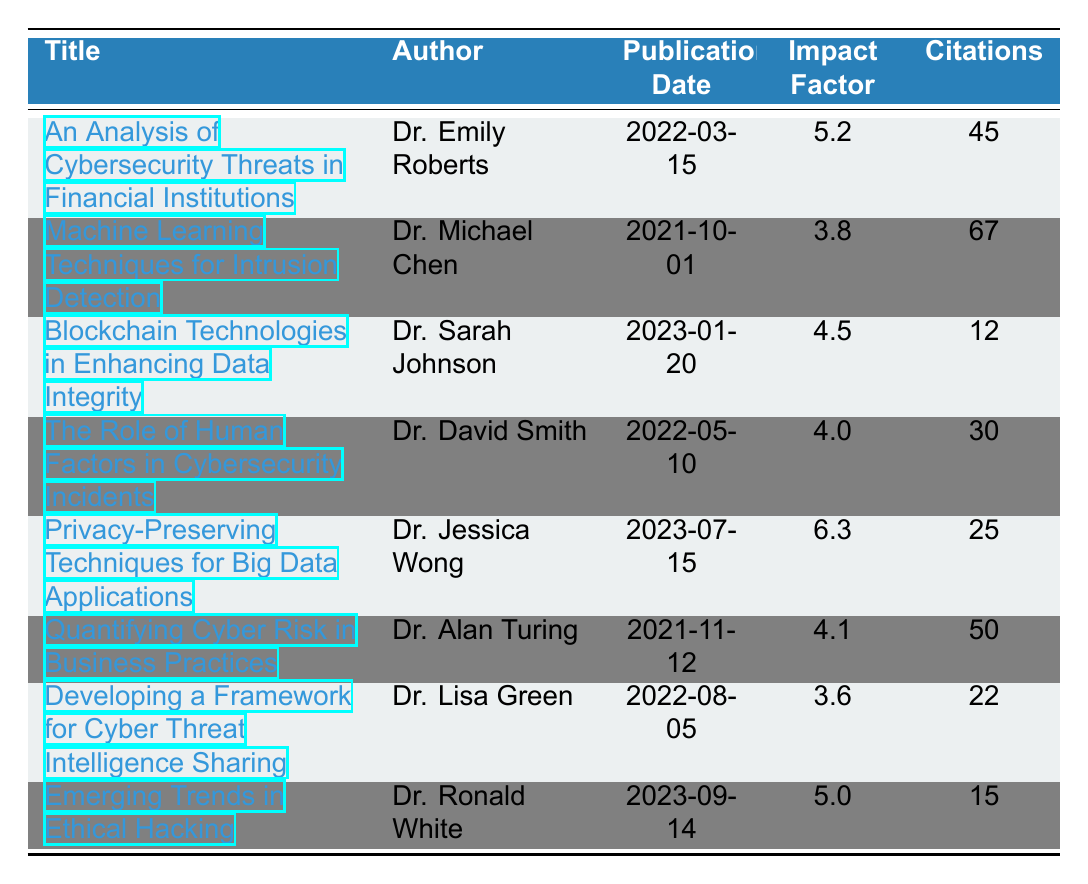What is the title of the publication with the highest impact factor? The highest impact factor in the table is 6.3, which corresponds to the publication titled "Privacy-Preserving Techniques for Big Data Applications."
Answer: Privacy-Preserving Techniques for Big Data Applications How many citations did "The Role of Human Factors in Cybersecurity Incidents" receive? By checking the row for "The Role of Human Factors in Cybersecurity Incidents," we see that it received 30 citations.
Answer: 30 What is the average impact factor of all publications listed? To calculate the average, we first sum the impact factors: 5.2 + 3.8 + 4.5 + 4.0 + 6.3 + 4.1 + 3.6 + 5.0 = 36.5. There are 8 publications, so the average impact factor is 36.5 / 8 = 4.5625, which can be rounded to 4.56.
Answer: 4.56 Did "Blockchain Technologies in Enhancing Data Integrity" have more citations than "Emerging Trends in Ethical Hacking"? "Blockchain Technologies in Enhancing Data Integrity" has 12 citations, while "Emerging Trends in Ethical Hacking" has 15 citations. Since 12 is less than 15, the answer is no.
Answer: No What is the difference in citations between the publication with the most citations and the least citations? "Machine Learning Techniques for Intrusion Detection" has the highest citations at 67, while "Blockchain Technologies in Enhancing Data Integrity" has the lowest citations at 12. The difference is 67 - 12 = 55.
Answer: 55 Which journal published the article with the most citations? The article with the most citations (67) is "Machine Learning Techniques for Intrusion Detection," which was published in the "International Journal of Information Security."
Answer: International Journal of Information Security How many publications were authored by Dr. David Smith? By scanning the table, we see that Dr. David Smith authored only one publication, "The Role of Human Factors in Cybersecurity Incidents."
Answer: 1 Is the impact factor of "Developing a Framework for Cyber Threat Intelligence Sharing" higher than 4.0? The impact factor for "Developing a Framework for Cyber Threat Intelligence Sharing" is 3.6, which is less than 4.0, so the answer is no.
Answer: No 